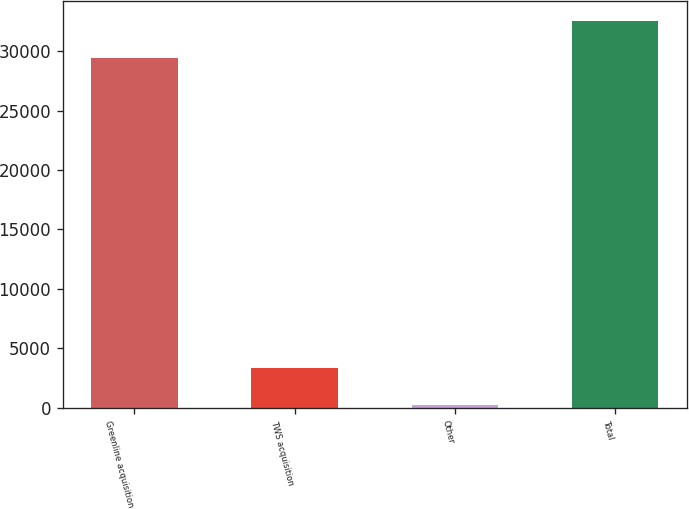<chart> <loc_0><loc_0><loc_500><loc_500><bar_chart><fcel>Greenline acquisition<fcel>TWS acquisition<fcel>Other<fcel>Total<nl><fcel>29405<fcel>3360.2<fcel>202<fcel>32563.2<nl></chart> 